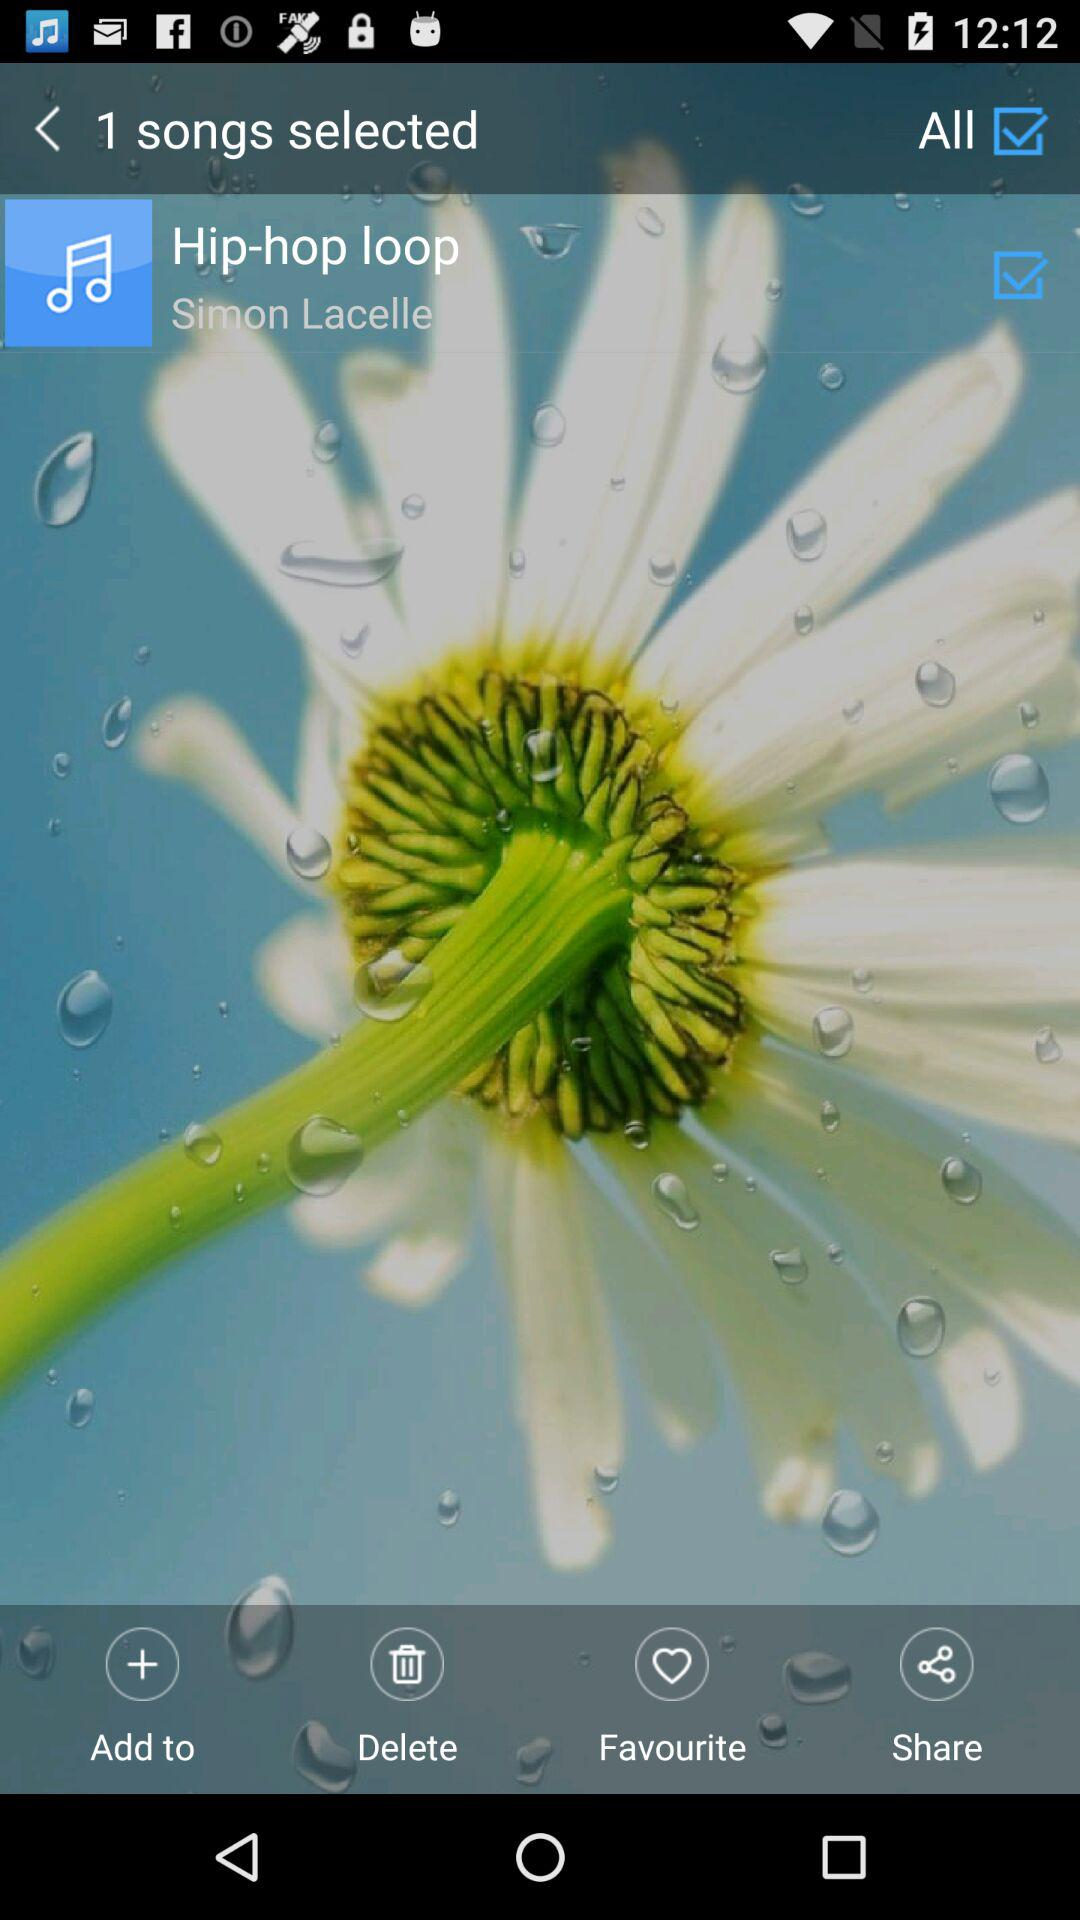How many songs are given to select? There is 1 song given to select. 